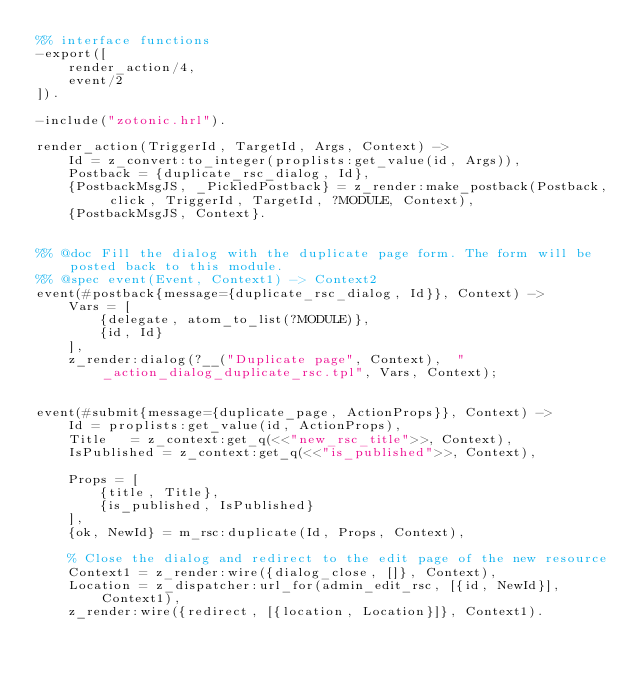<code> <loc_0><loc_0><loc_500><loc_500><_Erlang_>%% interface functions
-export([
    render_action/4,
    event/2
]).

-include("zotonic.hrl").

render_action(TriggerId, TargetId, Args, Context) ->
    Id = z_convert:to_integer(proplists:get_value(id, Args)),
    Postback = {duplicate_rsc_dialog, Id},
	{PostbackMsgJS, _PickledPostback} = z_render:make_postback(Postback, click, TriggerId, TargetId, ?MODULE, Context),
	{PostbackMsgJS, Context}.


%% @doc Fill the dialog with the duplicate page form. The form will be posted back to this module.
%% @spec event(Event, Context1) -> Context2
event(#postback{message={duplicate_rsc_dialog, Id}}, Context) ->
    Vars = [
        {delegate, atom_to_list(?MODULE)},
        {id, Id}
    ],
    z_render:dialog(?__("Duplicate page", Context),  "_action_dialog_duplicate_rsc.tpl", Vars, Context);


event(#submit{message={duplicate_page, ActionProps}}, Context) ->
    Id = proplists:get_value(id, ActionProps),
    Title   = z_context:get_q(<<"new_rsc_title">>, Context),
    IsPublished = z_context:get_q(<<"is_published">>, Context),

    Props = [
        {title, Title},
        {is_published, IsPublished}
    ],
    {ok, NewId} = m_rsc:duplicate(Id, Props, Context),

    % Close the dialog and redirect to the edit page of the new resource
    Context1 = z_render:wire({dialog_close, []}, Context),
    Location = z_dispatcher:url_for(admin_edit_rsc, [{id, NewId}], Context1),
    z_render:wire({redirect, [{location, Location}]}, Context1).
</code> 